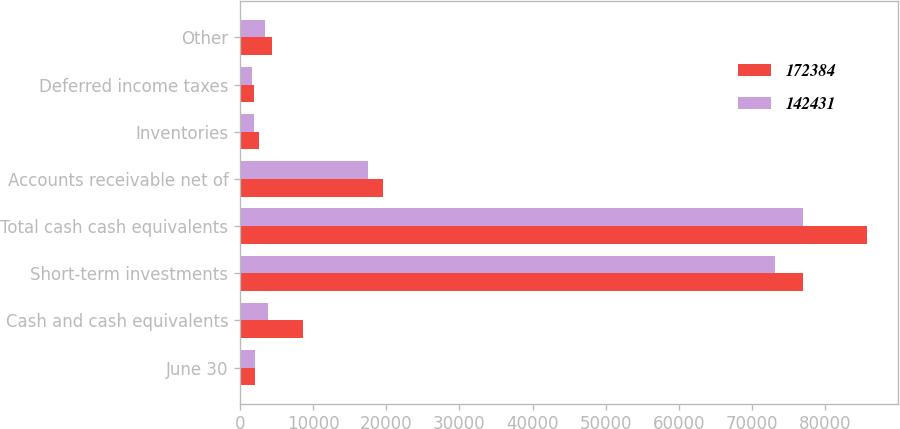Convert chart. <chart><loc_0><loc_0><loc_500><loc_500><stacked_bar_chart><ecel><fcel>June 30<fcel>Cash and cash equivalents<fcel>Short-term investments<fcel>Total cash cash equivalents<fcel>Accounts receivable net of<fcel>Inventories<fcel>Deferred income taxes<fcel>Other<nl><fcel>172384<fcel>2014<fcel>8669<fcel>77040<fcel>85709<fcel>19544<fcel>2660<fcel>1941<fcel>4392<nl><fcel>142431<fcel>2013<fcel>3804<fcel>73218<fcel>77022<fcel>17486<fcel>1938<fcel>1632<fcel>3388<nl></chart> 